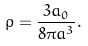Convert formula to latex. <formula><loc_0><loc_0><loc_500><loc_500>\rho = \frac { 3 a _ { 0 } } { 8 \pi a ^ { 3 } } .</formula> 